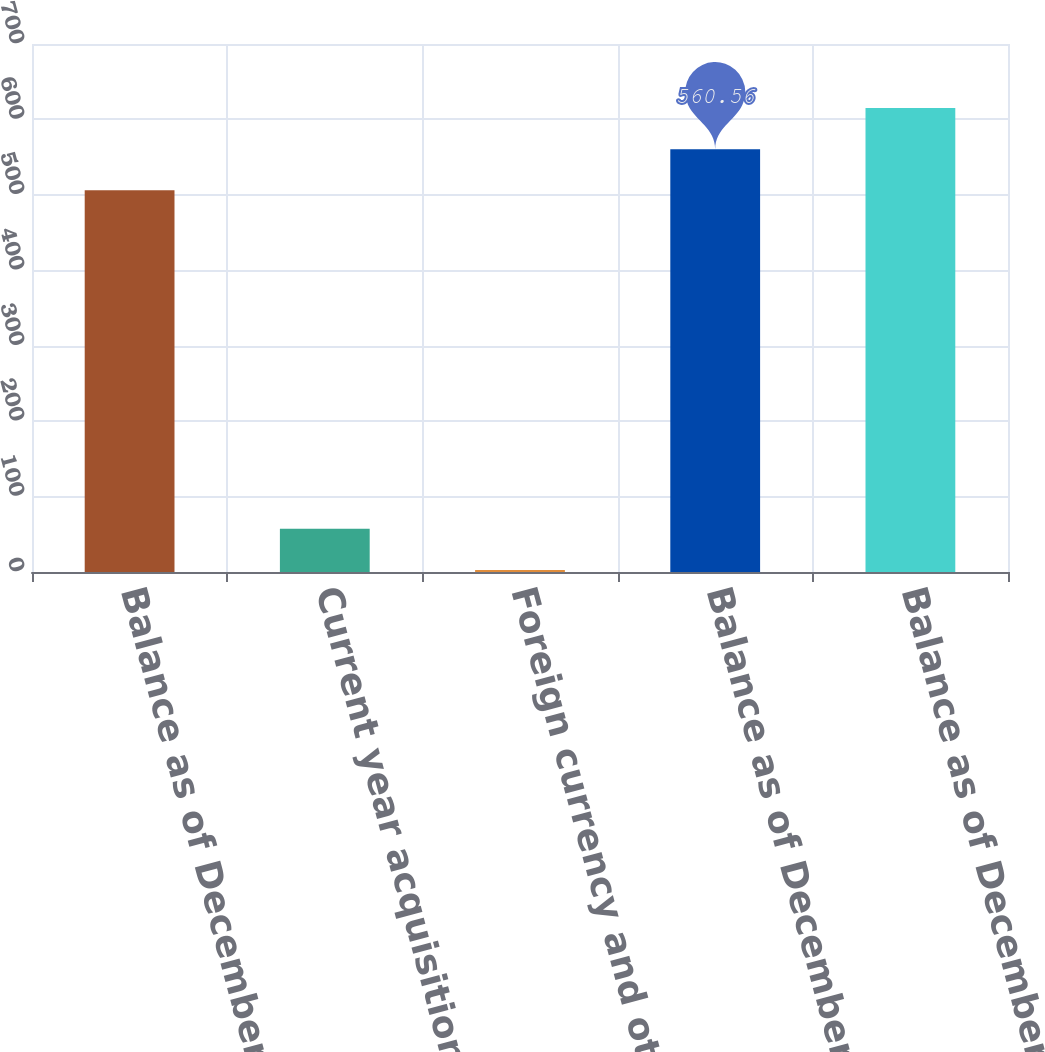Convert chart to OTSL. <chart><loc_0><loc_0><loc_500><loc_500><bar_chart><fcel>Balance as of December 31 2012<fcel>Current year acquisitions<fcel>Foreign currency and other<fcel>Balance as of December 31 2013<fcel>Balance as of December 31 2014<nl><fcel>506<fcel>57.36<fcel>2.8<fcel>560.56<fcel>615.12<nl></chart> 